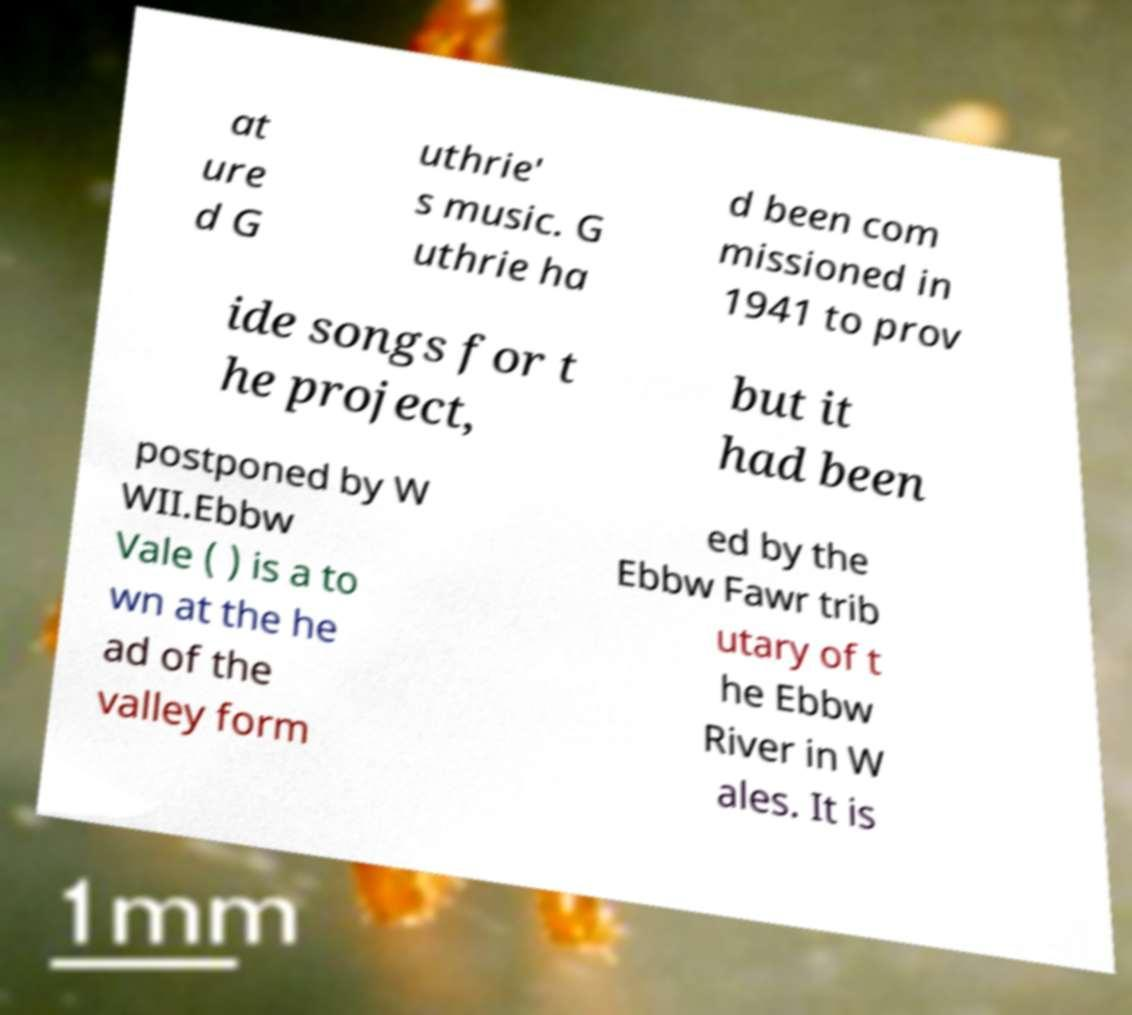There's text embedded in this image that I need extracted. Can you transcribe it verbatim? at ure d G uthrie' s music. G uthrie ha d been com missioned in 1941 to prov ide songs for t he project, but it had been postponed by W WII.Ebbw Vale ( ) is a to wn at the he ad of the valley form ed by the Ebbw Fawr trib utary of t he Ebbw River in W ales. It is 